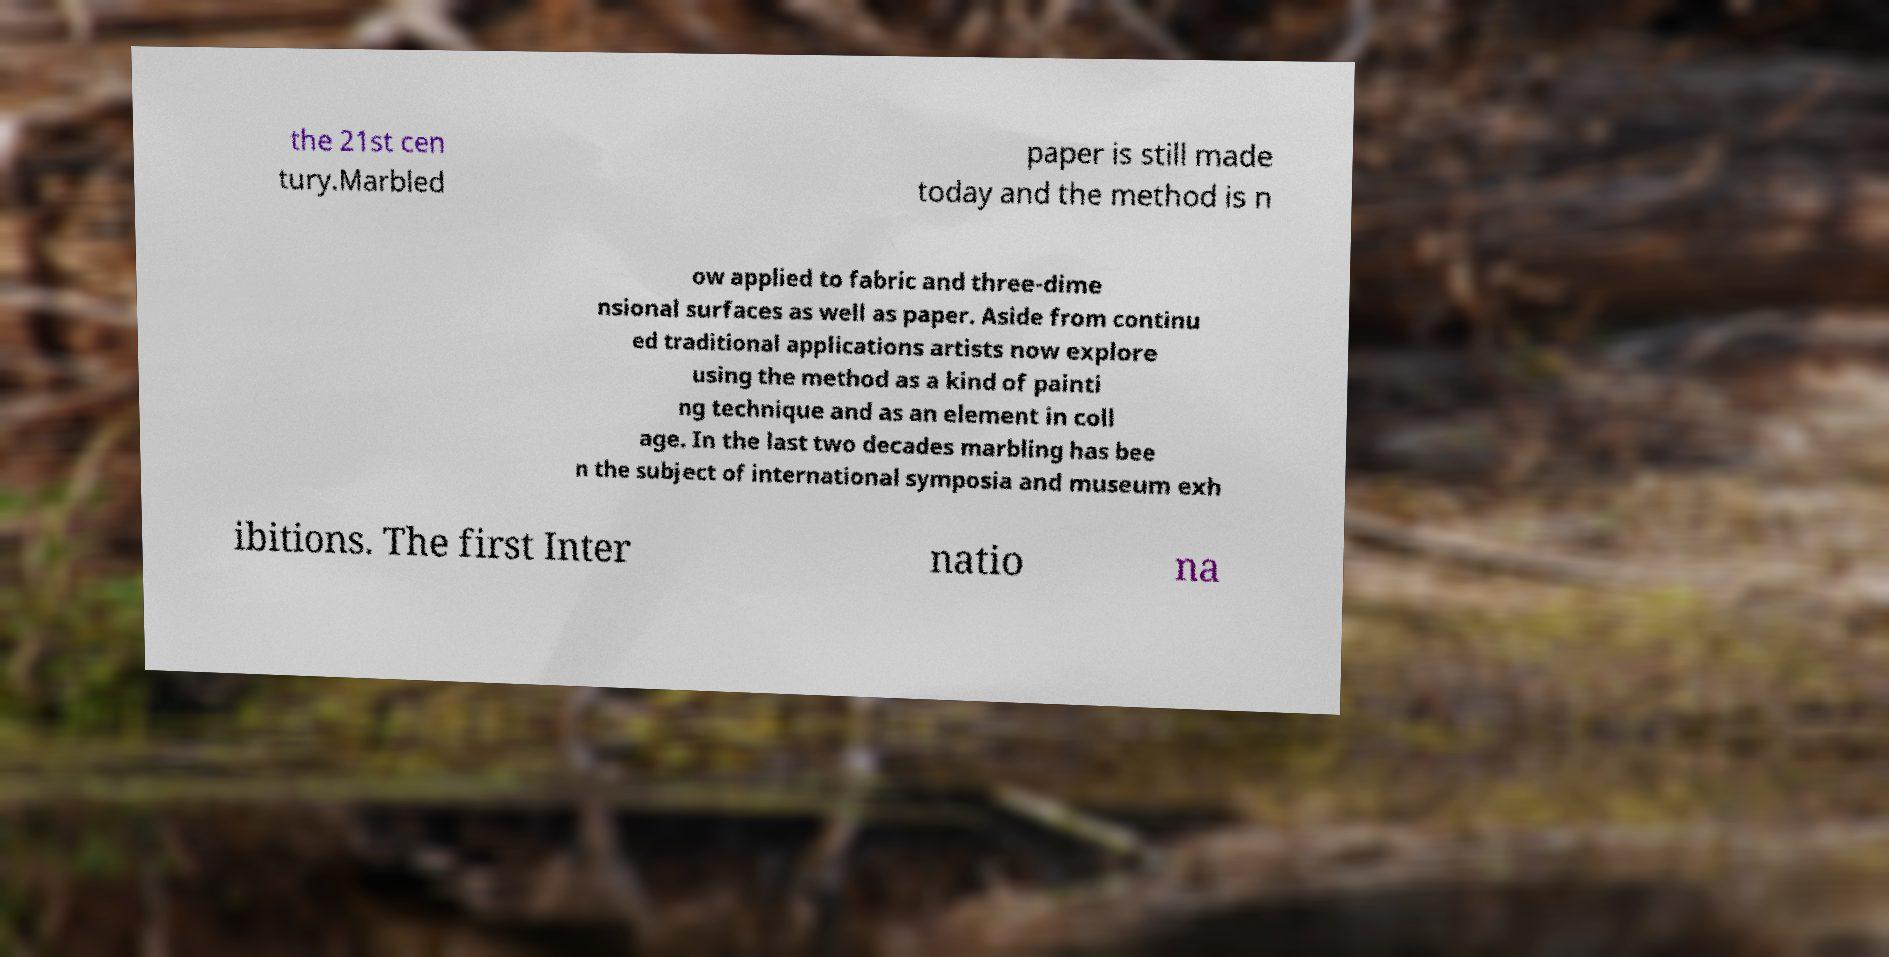Please identify and transcribe the text found in this image. the 21st cen tury.Marbled paper is still made today and the method is n ow applied to fabric and three-dime nsional surfaces as well as paper. Aside from continu ed traditional applications artists now explore using the method as a kind of painti ng technique and as an element in coll age. In the last two decades marbling has bee n the subject of international symposia and museum exh ibitions. The first Inter natio na 